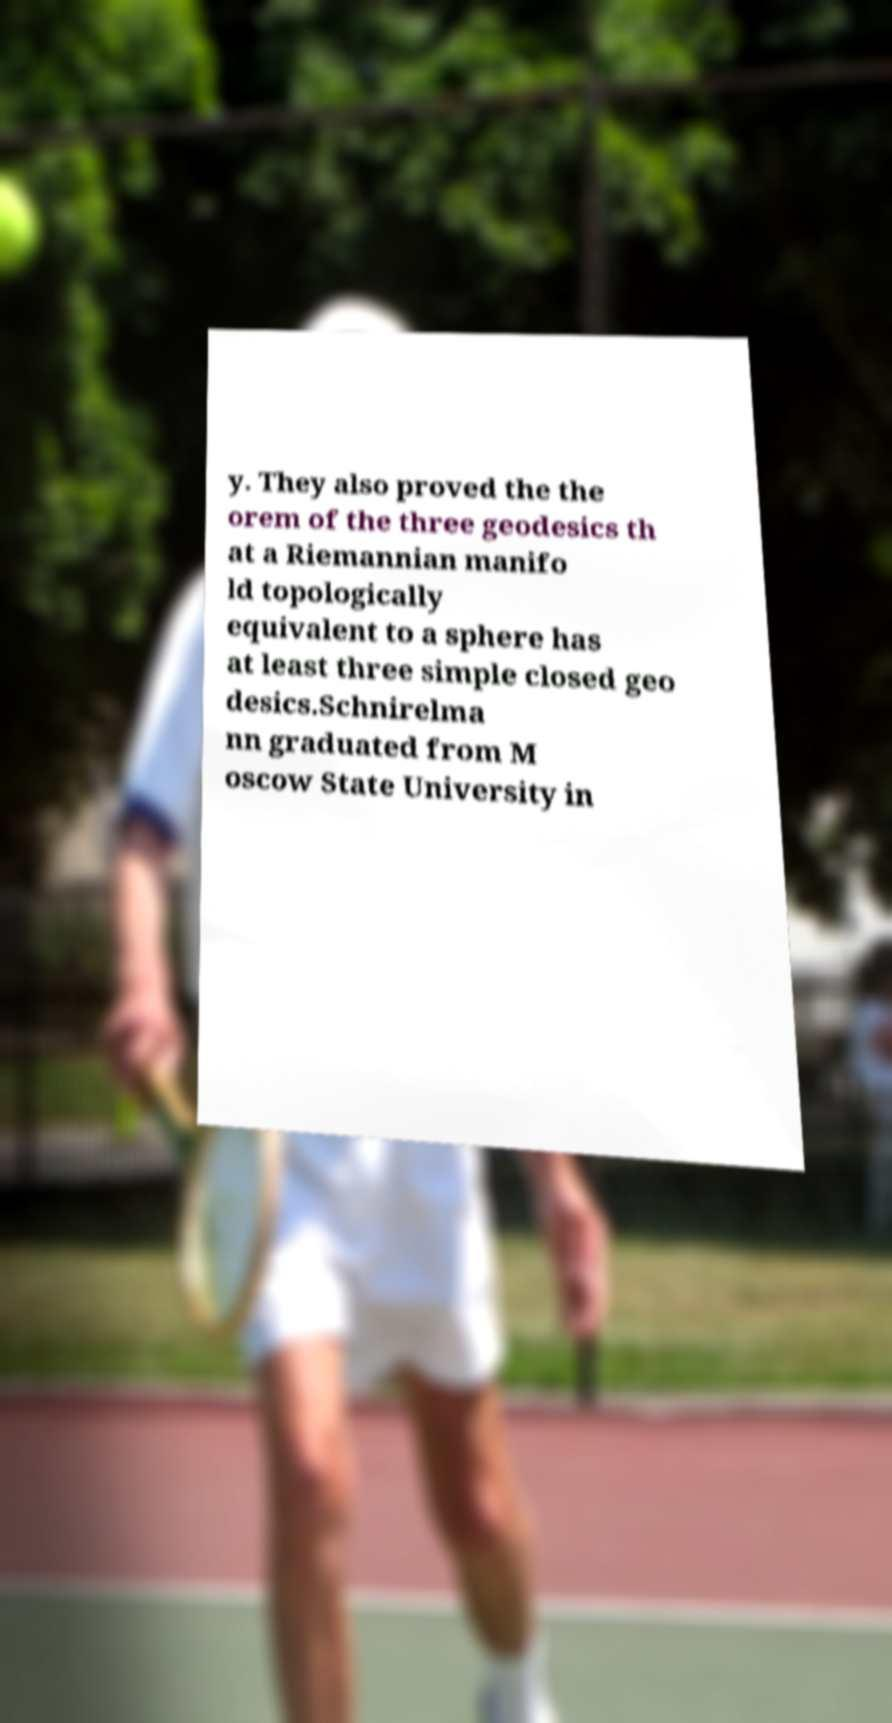I need the written content from this picture converted into text. Can you do that? y. They also proved the the orem of the three geodesics th at a Riemannian manifo ld topologically equivalent to a sphere has at least three simple closed geo desics.Schnirelma nn graduated from M oscow State University in 